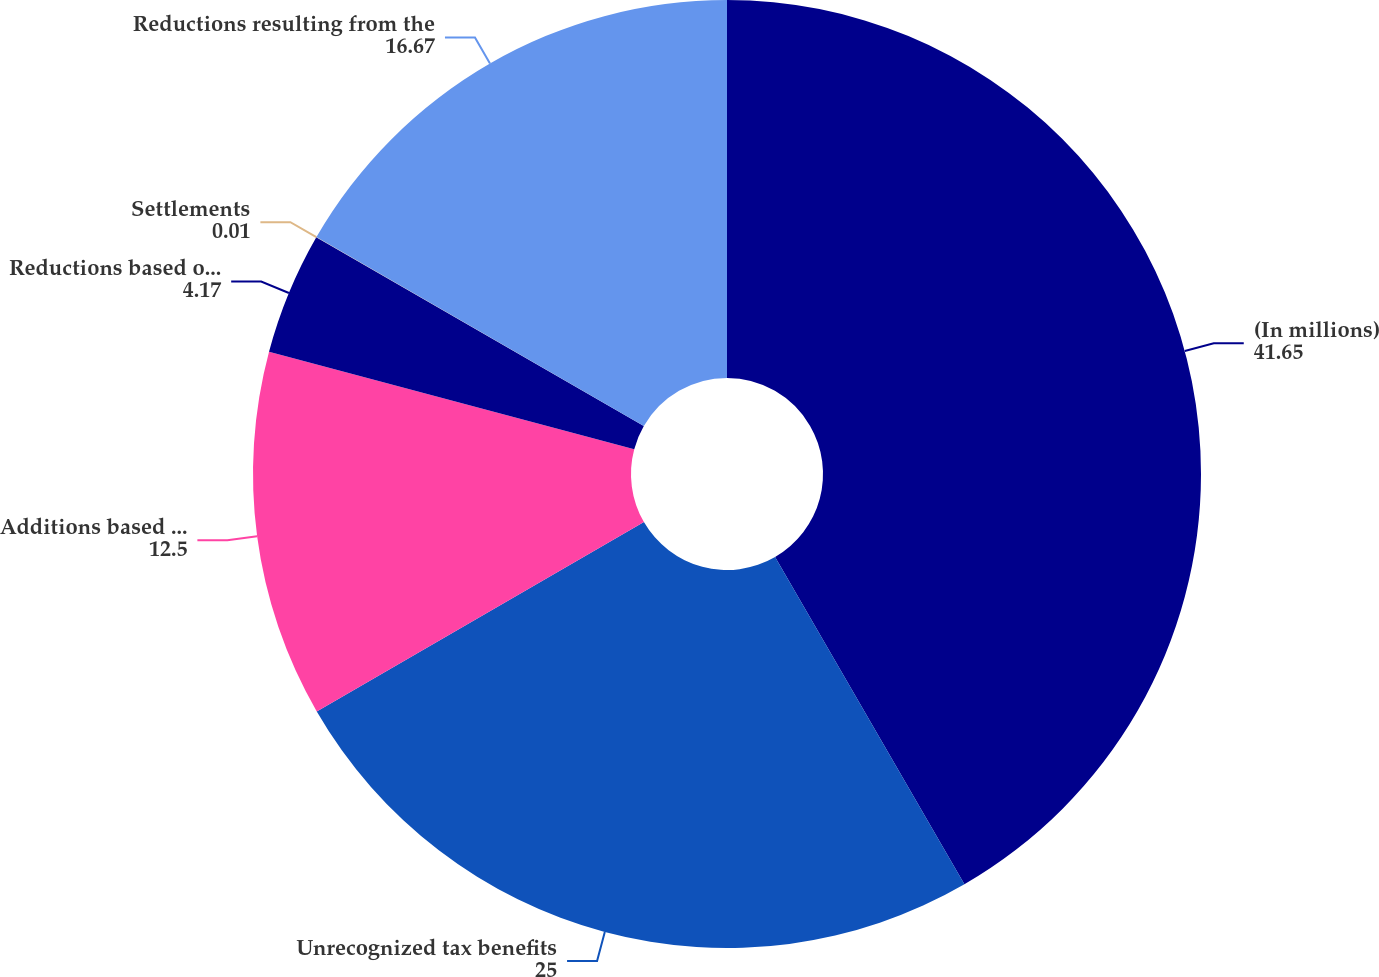<chart> <loc_0><loc_0><loc_500><loc_500><pie_chart><fcel>(In millions)<fcel>Unrecognized tax benefits<fcel>Additions based on tax<fcel>Reductions based on tax<fcel>Settlements<fcel>Reductions resulting from the<nl><fcel>41.65%<fcel>25.0%<fcel>12.5%<fcel>4.17%<fcel>0.01%<fcel>16.67%<nl></chart> 